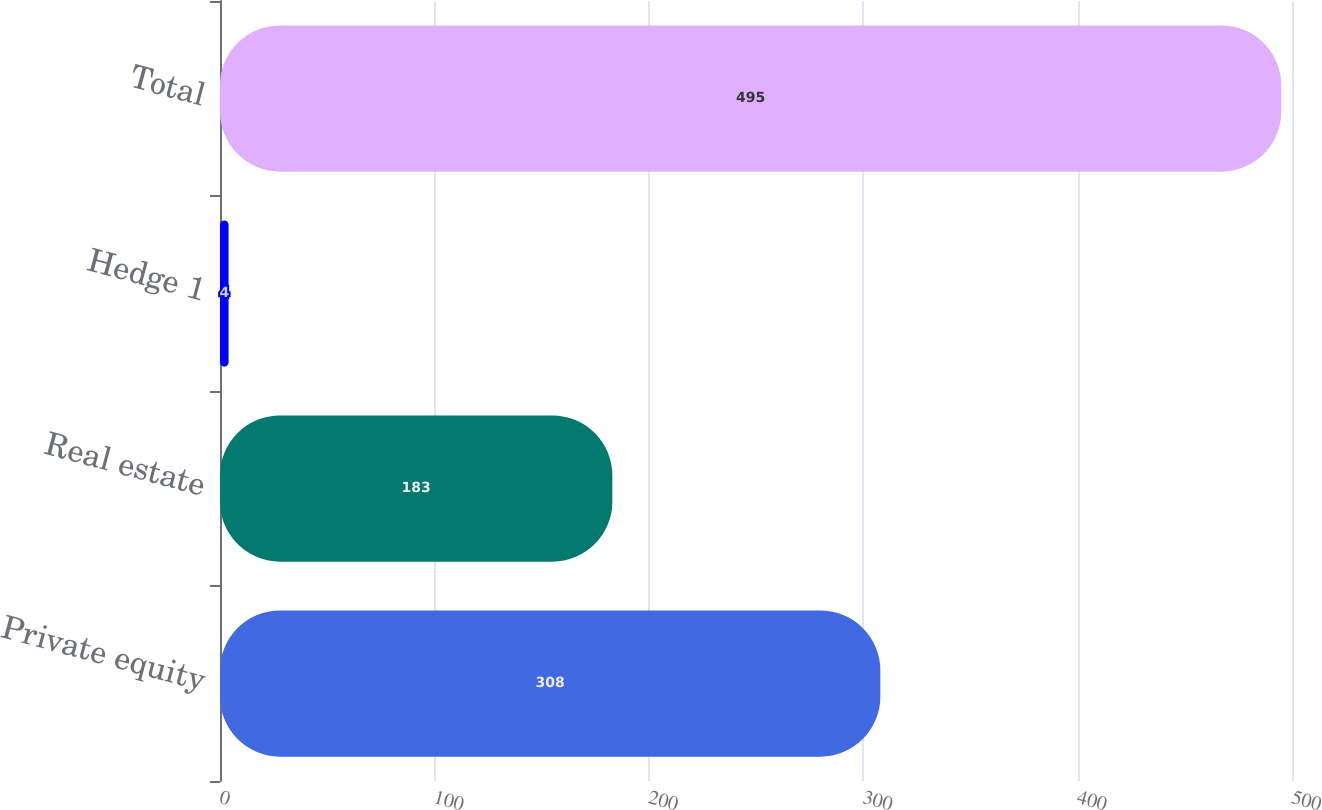Convert chart. <chart><loc_0><loc_0><loc_500><loc_500><bar_chart><fcel>Private equity<fcel>Real estate<fcel>Hedge 1<fcel>Total<nl><fcel>308<fcel>183<fcel>4<fcel>495<nl></chart> 